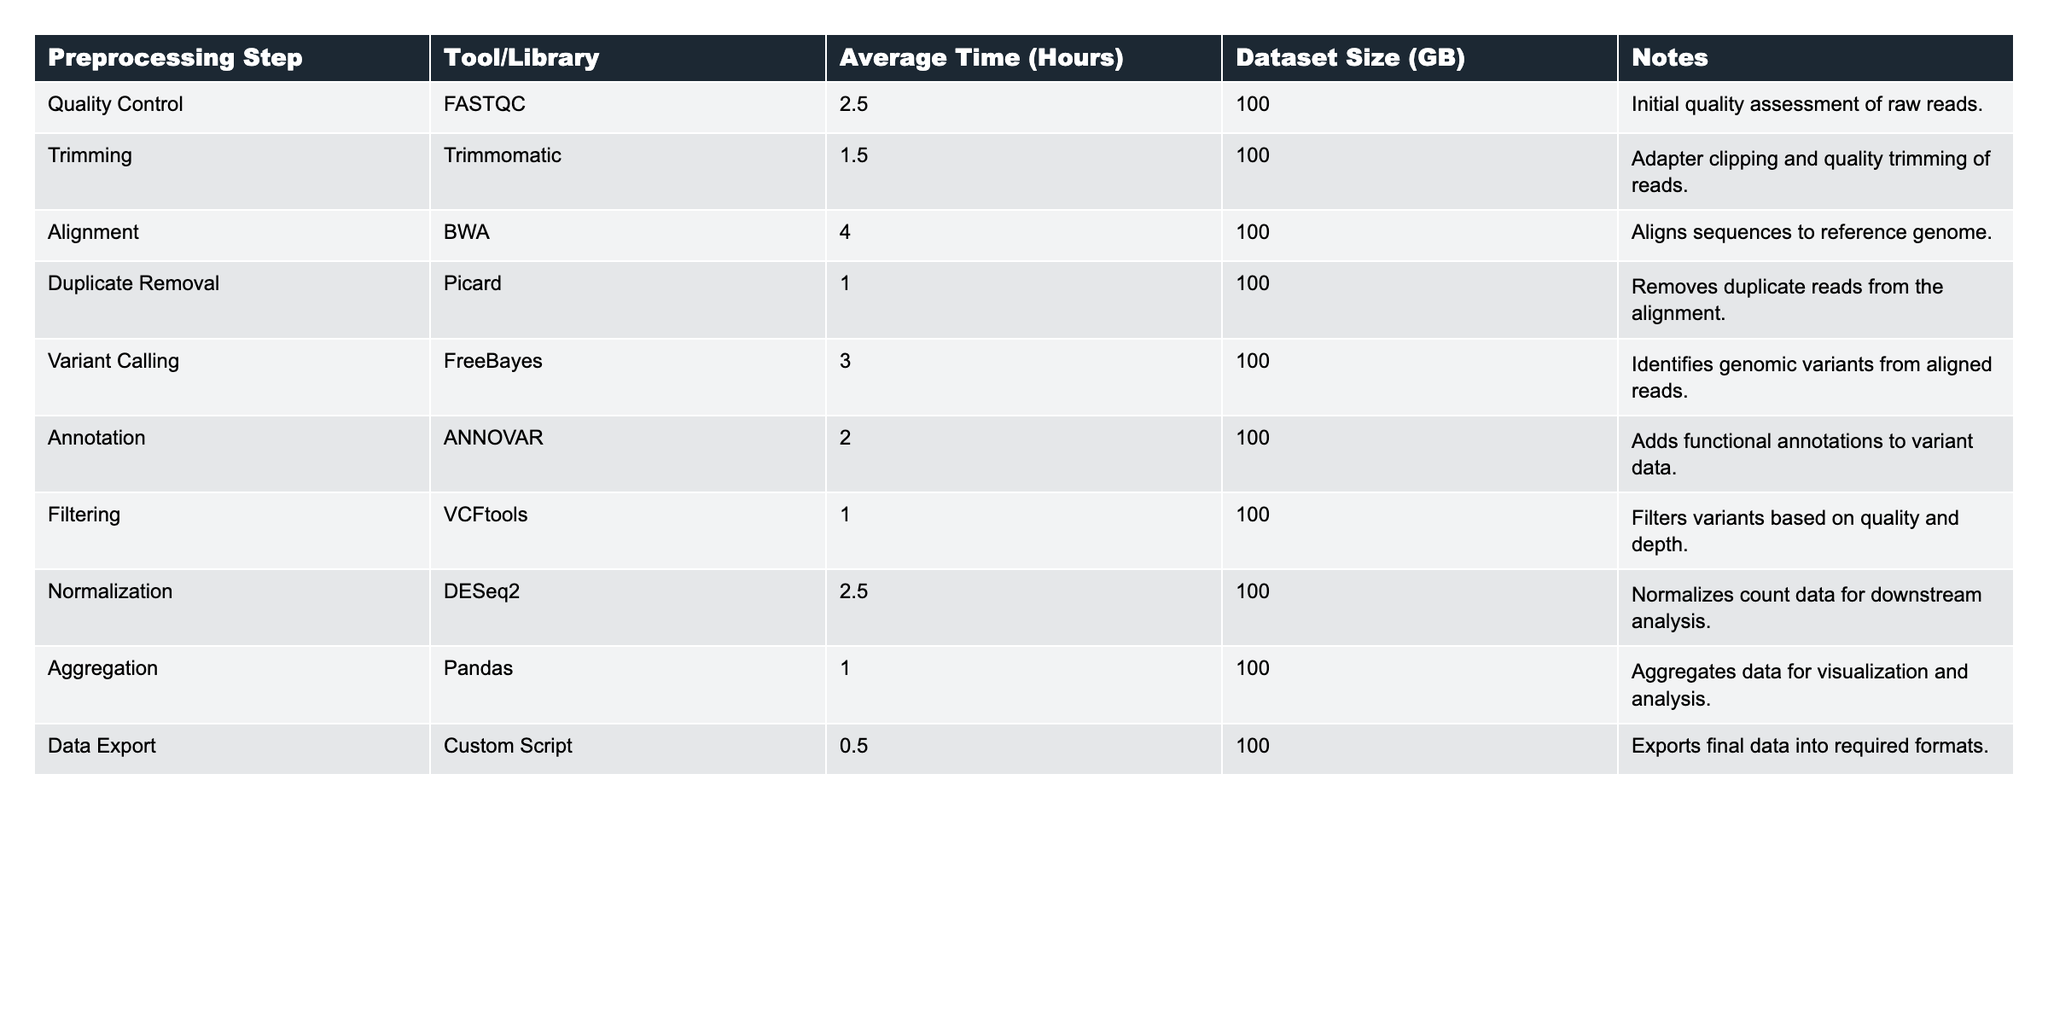What is the average time taken for the Variant Calling step? The table shows that the average time for the Variant Calling step is 3.0 hours.
Answer: 3.0 hours Which preprocessing step takes the least time? By looking at the Average Time column, the Data Export step takes the least time at 0.5 hours.
Answer: Data Export What is the total time taken for all preprocessing steps? Adding up the average times: 2.5 + 1.5 + 4.0 + 1.0 + 3.0 + 2.0 + 1.0 + 2.5 + 1.0 + 0.5 = 19.0 hours.
Answer: 19.0 hours True or False: The alignment step takes more time than both the trimming and duplicate removal steps combined. The alignment step takes 4.0 hours, while trimming and duplicate removal together take 1.5 + 1.0 = 2.5 hours, which means 4.0 > 2.5.
Answer: True What is the average time taken across all preprocessing steps? To find the average, I add all average times (19.0 hours) and divide by the number of steps (10): 19.0 / 10 = 1.9 hours.
Answer: 1.9 hours Which tool/library is used for normalization, and how long does it take? The table indicates that DESeq2 is the tool/library used for normalization, which takes 2.5 hours.
Answer: DESeq2, 2.5 hours Is the time taken for Filtering and Aggregation steps the same? Both the Filtering and Aggregation steps take 1.0 hour each as seen in the Average Time column.
Answer: Yes If I wanted to perform a quality control check, how many hours would that take? The table clearly states that the Quality Control step takes 2.5 hours.
Answer: 2.5 hours Which two steps combined take the same amount of time as the Alignment step? Duplicate Removal (1.0 hours) and Data Export (0.5 hours) together take 1.5 hours, which does not equal Alignment. However, Trimming (1.5 hours) and Filtering (1.0 hours) together yield 2.5 hours, thus no other steps exactly equal 4.0.
Answer: None What is the difference in hours between the time taken for Variant Calling and the time taken for Duplicate Removal? Variant Calling takes 3.0 hours and Duplicate Removal takes 1.0 hours, thus the difference is 3.0 - 1.0 = 2.0 hours.
Answer: 2.0 hours Which preprocessing steps collectively take less than 5 hours? Adding times: Quality Control (2.5) + Trimming (1.5) + Duplicate Removal (1.0) = 5.0 hours, so the combination of Quality Control, Trimming, and Duplicate Removal meets the required time frame.
Answer: Quality Control, Trimming, and Duplicate Removal 